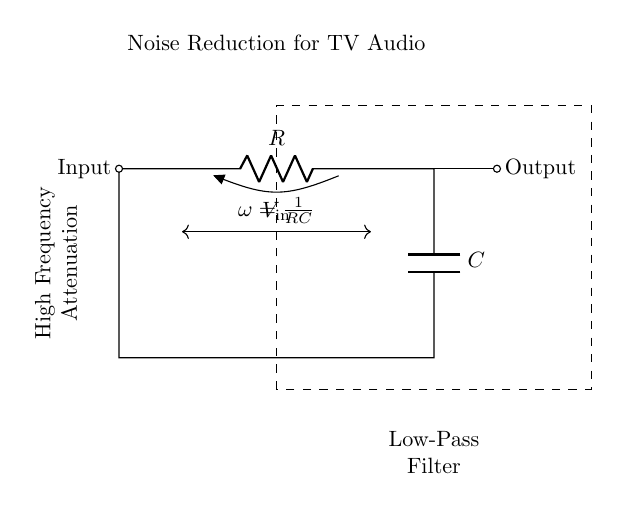What components are in this low-pass filter? The components in the low-pass filter are a resistor and a capacitor. These components are typically used to control the frequency response of the circuit, allowing low frequencies to pass while attenuating high frequencies.
Answer: Resistor and Capacitor What type of filter is represented in the diagram? The diagram represents a low-pass filter, which is designed to allow signals with a frequency lower than a certain cutoff frequency to pass through, while attenuating higher-frequency signals.
Answer: Low-pass filter What is the purpose of this circuit? The purpose of this circuit is noise reduction in television audio systems, which involves filtering out high-frequency noise from the audio signal, allowing for clearer sound reproduction.
Answer: Noise reduction What is the cutoff frequency formula shown in the circuit? The cutoff frequency formula is expressed as omega equals one over RC, where R is the resistance and C is the capacitance, representing the frequency at which the output voltage drops to approximately 70.7% of the input signal.
Answer: One over RC How does this circuit affect high-frequency signals? This circuit attenuates high-frequency signals, meaning that it reduces the amplitude of those signals, thereby filtering them out and allowing only lower frequencies to pass through the output.
Answer: Attenuates What happens to the output when the input frequency increases? As the input frequency increases beyond the cutoff frequency, the output signal's amplitude decreases significantly, which means that fewer high-frequency components will be present in the output compared to the input.
Answer: Decreases amplitude 